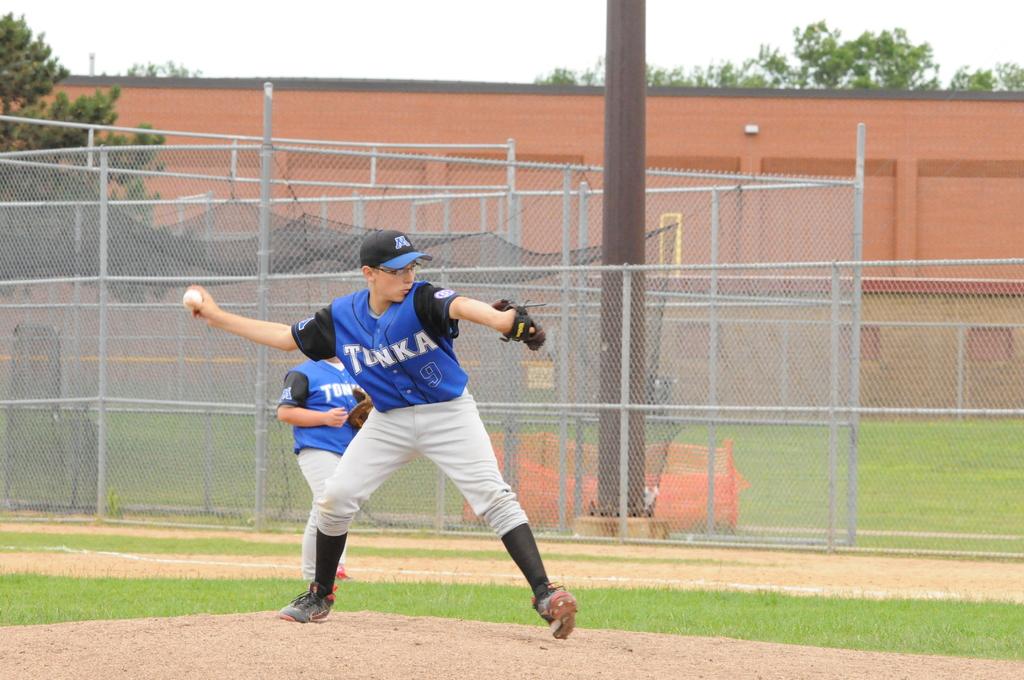What team is pitching?
Offer a very short reply. Tonka. 